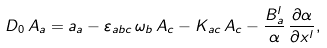<formula> <loc_0><loc_0><loc_500><loc_500>D _ { 0 } \, { A } _ { a } = a _ { a } - \varepsilon _ { a b c } \, \omega _ { b } \, { A } _ { c } - K _ { a c } \, { A } _ { c } - \frac { B _ { a } ^ { l } } { \alpha } \, \frac { \partial { \alpha } } { \partial x ^ { l } } ,</formula> 